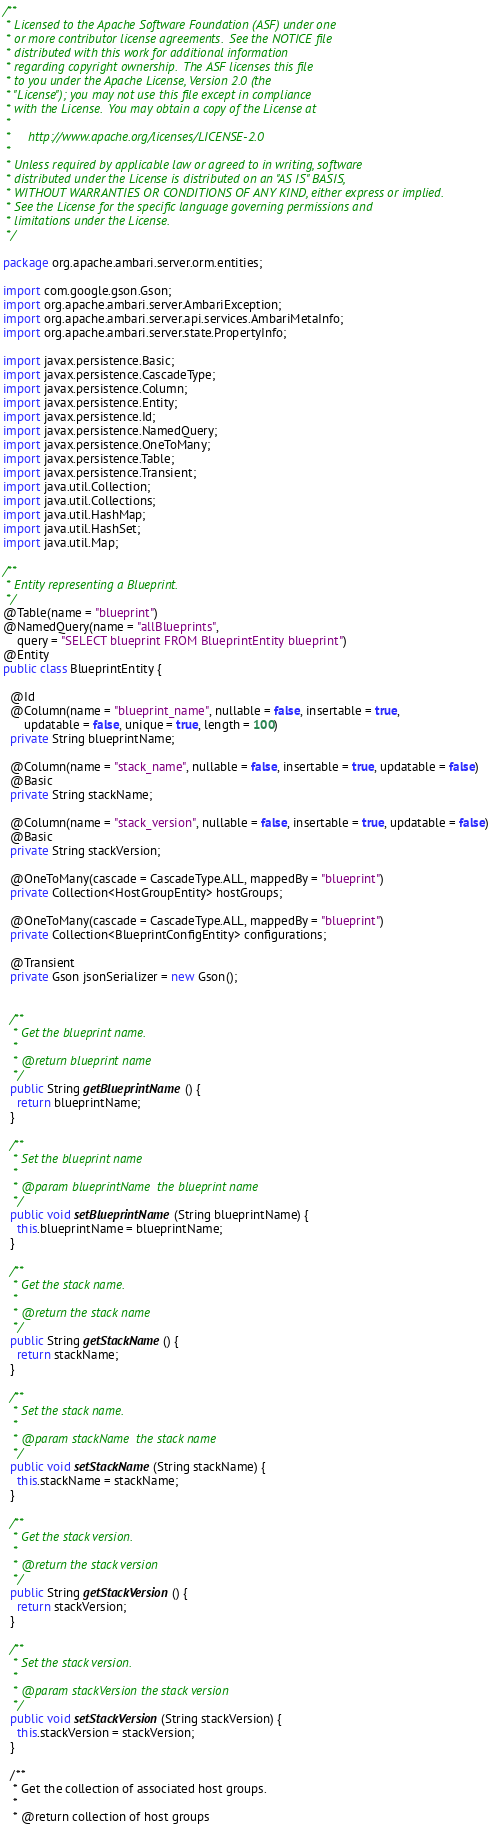Convert code to text. <code><loc_0><loc_0><loc_500><loc_500><_Java_>/**
 * Licensed to the Apache Software Foundation (ASF) under one
 * or more contributor license agreements.  See the NOTICE file
 * distributed with this work for additional information
 * regarding copyright ownership.  The ASF licenses this file
 * to you under the Apache License, Version 2.0 (the
 * "License"); you may not use this file except in compliance
 * with the License.  You may obtain a copy of the License at
 *
 *     http://www.apache.org/licenses/LICENSE-2.0
 *
 * Unless required by applicable law or agreed to in writing, software
 * distributed under the License is distributed on an "AS IS" BASIS,
 * WITHOUT WARRANTIES OR CONDITIONS OF ANY KIND, either express or implied.
 * See the License for the specific language governing permissions and
 * limitations under the License.
 */

package org.apache.ambari.server.orm.entities;

import com.google.gson.Gson;
import org.apache.ambari.server.AmbariException;
import org.apache.ambari.server.api.services.AmbariMetaInfo;
import org.apache.ambari.server.state.PropertyInfo;

import javax.persistence.Basic;
import javax.persistence.CascadeType;
import javax.persistence.Column;
import javax.persistence.Entity;
import javax.persistence.Id;
import javax.persistence.NamedQuery;
import javax.persistence.OneToMany;
import javax.persistence.Table;
import javax.persistence.Transient;
import java.util.Collection;
import java.util.Collections;
import java.util.HashMap;
import java.util.HashSet;
import java.util.Map;

/**
 * Entity representing a Blueprint.
 */
@Table(name = "blueprint")
@NamedQuery(name = "allBlueprints",
    query = "SELECT blueprint FROM BlueprintEntity blueprint")
@Entity
public class BlueprintEntity {

  @Id
  @Column(name = "blueprint_name", nullable = false, insertable = true,
      updatable = false, unique = true, length = 100)
  private String blueprintName;

  @Column(name = "stack_name", nullable = false, insertable = true, updatable = false)
  @Basic
  private String stackName;

  @Column(name = "stack_version", nullable = false, insertable = true, updatable = false)
  @Basic
  private String stackVersion;

  @OneToMany(cascade = CascadeType.ALL, mappedBy = "blueprint")
  private Collection<HostGroupEntity> hostGroups;

  @OneToMany(cascade = CascadeType.ALL, mappedBy = "blueprint")
  private Collection<BlueprintConfigEntity> configurations;

  @Transient
  private Gson jsonSerializer = new Gson();


  /**
   * Get the blueprint name.
   *
   * @return blueprint name
   */
  public String getBlueprintName() {
    return blueprintName;
  }

  /**
   * Set the blueprint name
   *
   * @param blueprintName  the blueprint name
   */
  public void setBlueprintName(String blueprintName) {
    this.blueprintName = blueprintName;
  }

  /**
   * Get the stack name.
   *
   * @return the stack name
   */
  public String getStackName() {
    return stackName;
  }

  /**
   * Set the stack name.
   *
   * @param stackName  the stack name
   */
  public void setStackName(String stackName) {
    this.stackName = stackName;
  }

  /**
   * Get the stack version.
   *
   * @return the stack version
   */
  public String getStackVersion() {
    return stackVersion;
  }

  /**
   * Set the stack version.
   *
   * @param stackVersion the stack version
   */
  public void setStackVersion(String stackVersion) {
    this.stackVersion = stackVersion;
  }

  /**
   * Get the collection of associated host groups.
   *
   * @return collection of host groups</code> 